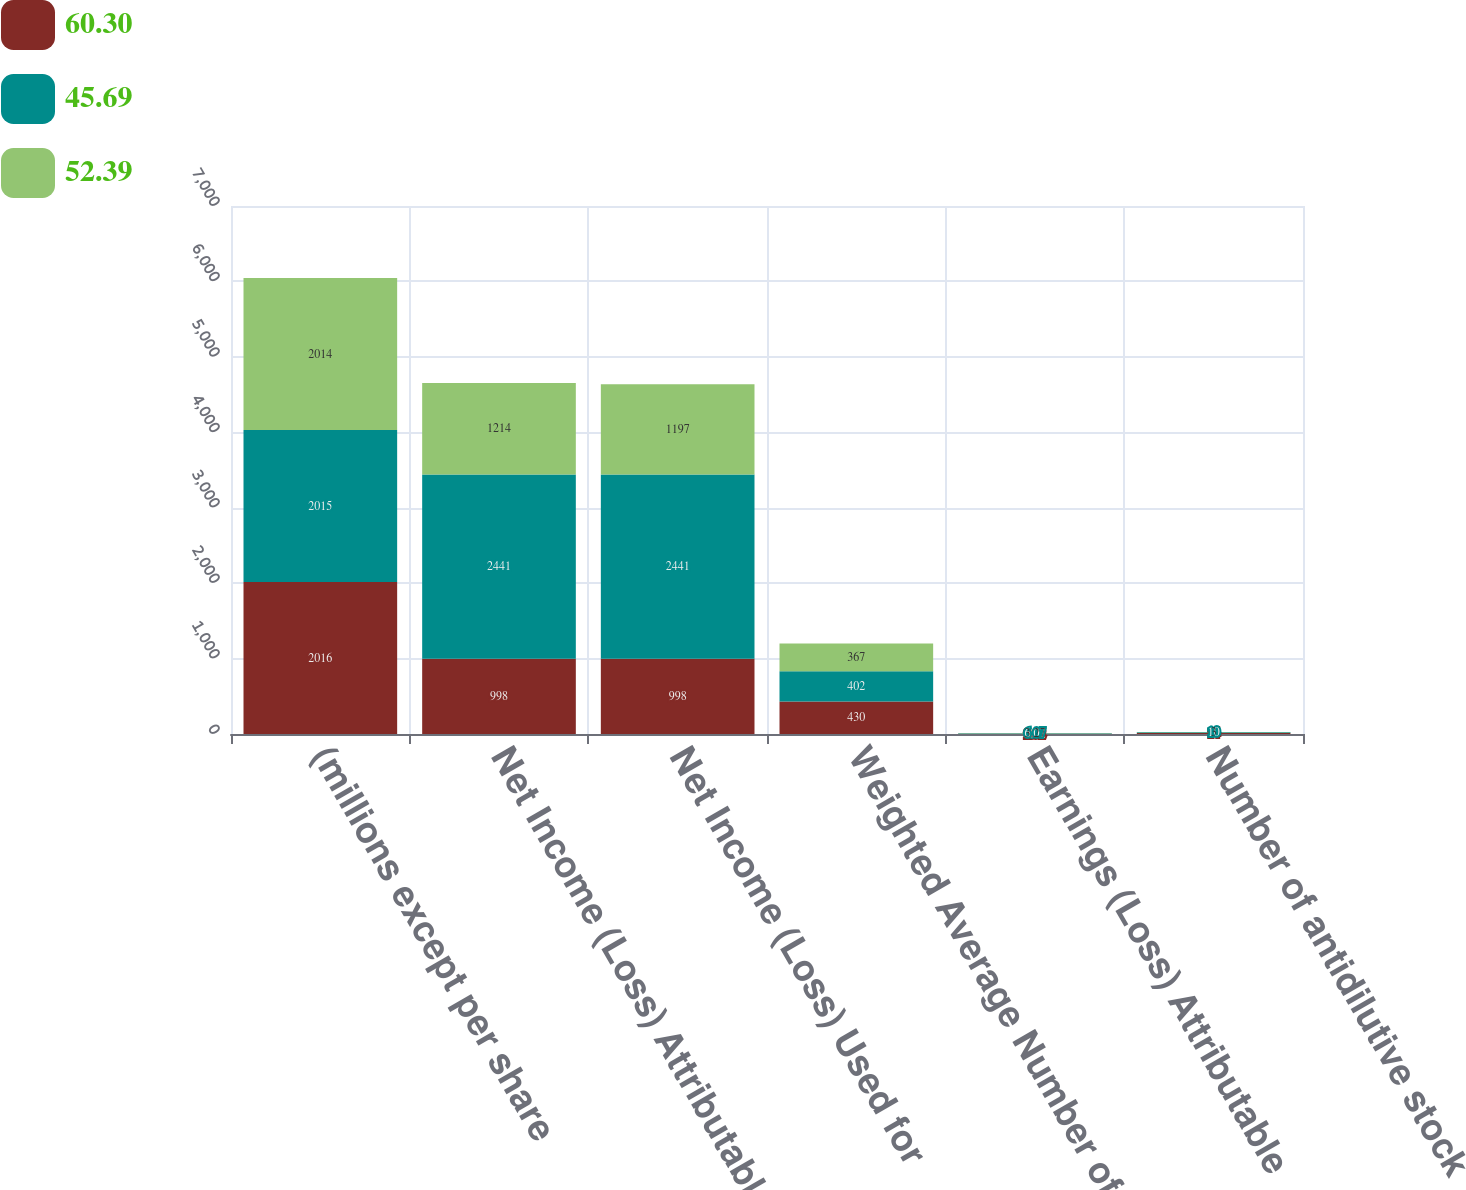Convert chart to OTSL. <chart><loc_0><loc_0><loc_500><loc_500><stacked_bar_chart><ecel><fcel>(millions except per share<fcel>Net Income (Loss) Attributable<fcel>Net Income (Loss) Used for<fcel>Weighted Average Number of<fcel>Earnings (Loss) Attributable<fcel>Number of antidilutive stock<nl><fcel>60.3<fcel>2016<fcel>998<fcel>998<fcel>430<fcel>2.32<fcel>14<nl><fcel>45.69<fcel>2015<fcel>2441<fcel>2441<fcel>402<fcel>6.07<fcel>10<nl><fcel>52.39<fcel>2014<fcel>1214<fcel>1197<fcel>367<fcel>3.27<fcel>3<nl></chart> 